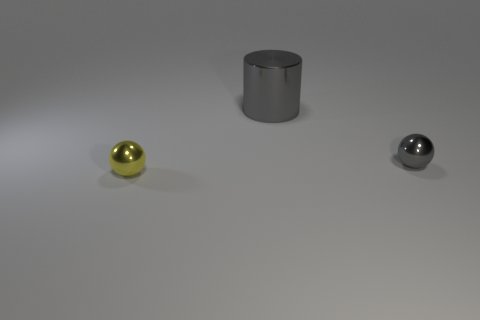Are there any other things that have the same shape as the big gray metallic thing?
Offer a terse response. No. How many big gray shiny things are on the right side of the gray shiny thing on the right side of the big gray shiny cylinder?
Provide a succinct answer. 0. How many other objects are the same material as the large thing?
Make the answer very short. 2. There is a tiny metal thing in front of the gray thing that is in front of the large gray metallic thing; what is its shape?
Ensure brevity in your answer.  Sphere. There is a gray object behind the tiny gray thing; what size is it?
Provide a succinct answer. Large. There is another large object that is made of the same material as the yellow object; what shape is it?
Your answer should be very brief. Cylinder. What is the color of the tiny shiny object behind the yellow sphere?
Provide a succinct answer. Gray. Do the tiny thing that is on the right side of the tiny yellow object and the large metal cylinder have the same color?
Offer a terse response. Yes. What is the material of the other small object that is the same shape as the tiny gray shiny object?
Your response must be concise. Metal. How many other metal spheres have the same size as the yellow sphere?
Your response must be concise. 1. 